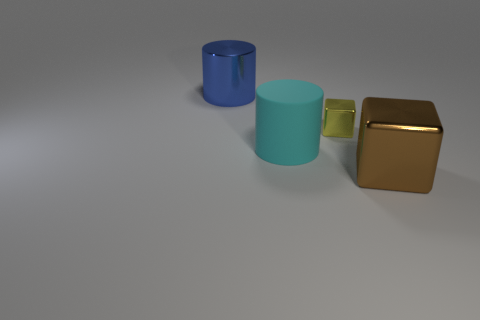What number of blocks have the same size as the brown object? 0 